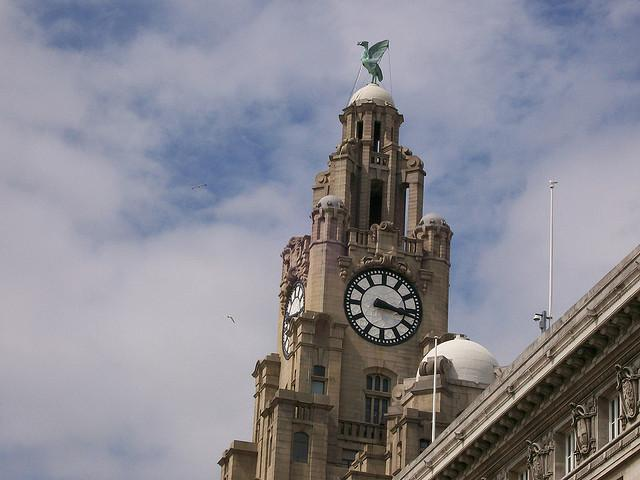Why are there ropes on the statue? support 